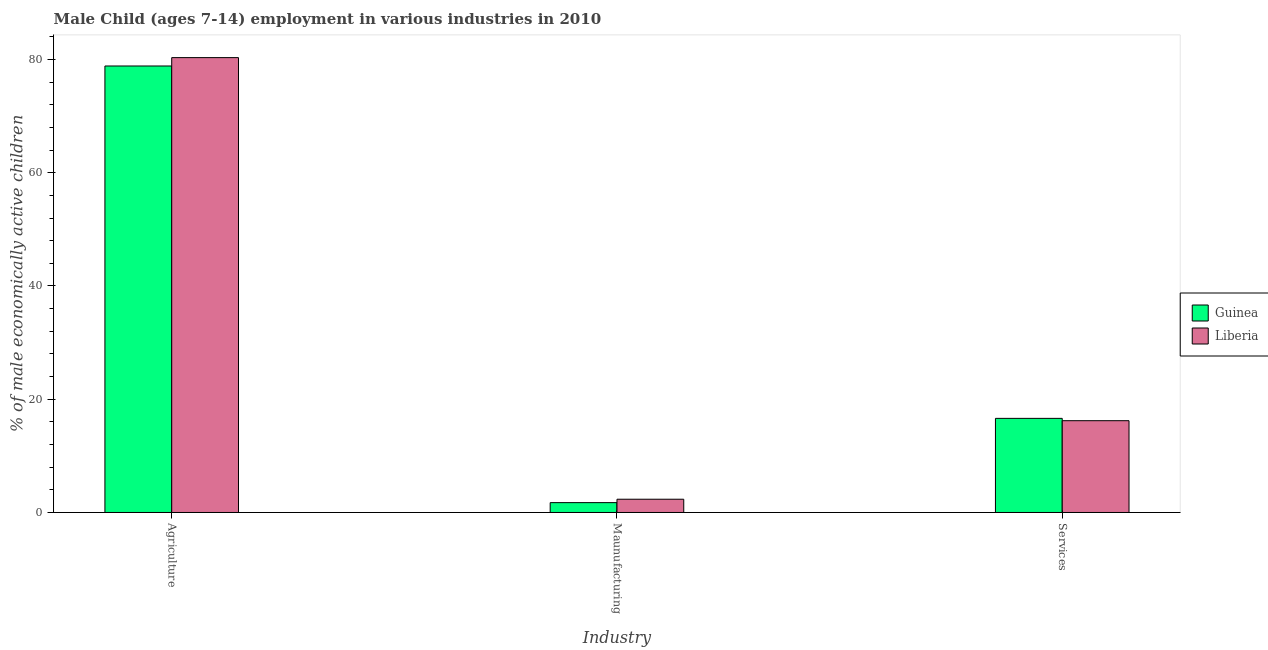How many groups of bars are there?
Ensure brevity in your answer.  3. Are the number of bars on each tick of the X-axis equal?
Provide a short and direct response. Yes. How many bars are there on the 2nd tick from the left?
Provide a short and direct response. 2. What is the label of the 3rd group of bars from the left?
Your answer should be very brief. Services. What is the percentage of economically active children in services in Liberia?
Your answer should be compact. 16.21. Across all countries, what is the maximum percentage of economically active children in services?
Your answer should be compact. 16.62. Across all countries, what is the minimum percentage of economically active children in agriculture?
Provide a succinct answer. 78.85. In which country was the percentage of economically active children in agriculture maximum?
Your answer should be very brief. Liberia. In which country was the percentage of economically active children in manufacturing minimum?
Ensure brevity in your answer.  Guinea. What is the total percentage of economically active children in agriculture in the graph?
Your answer should be compact. 159.18. What is the difference between the percentage of economically active children in agriculture in Guinea and that in Liberia?
Your response must be concise. -1.48. What is the difference between the percentage of economically active children in manufacturing in Guinea and the percentage of economically active children in agriculture in Liberia?
Offer a terse response. -78.59. What is the average percentage of economically active children in agriculture per country?
Ensure brevity in your answer.  79.59. What is the difference between the percentage of economically active children in services and percentage of economically active children in agriculture in Guinea?
Ensure brevity in your answer.  -62.23. What is the ratio of the percentage of economically active children in services in Liberia to that in Guinea?
Offer a very short reply. 0.98. Is the percentage of economically active children in manufacturing in Guinea less than that in Liberia?
Give a very brief answer. Yes. What is the difference between the highest and the second highest percentage of economically active children in agriculture?
Provide a succinct answer. 1.48. What is the difference between the highest and the lowest percentage of economically active children in manufacturing?
Your answer should be compact. 0.6. What does the 1st bar from the left in Maunufacturing represents?
Provide a short and direct response. Guinea. What does the 1st bar from the right in Maunufacturing represents?
Give a very brief answer. Liberia. How many countries are there in the graph?
Ensure brevity in your answer.  2. What is the difference between two consecutive major ticks on the Y-axis?
Offer a very short reply. 20. Does the graph contain any zero values?
Make the answer very short. No. Does the graph contain grids?
Give a very brief answer. No. Where does the legend appear in the graph?
Your answer should be compact. Center right. What is the title of the graph?
Provide a succinct answer. Male Child (ages 7-14) employment in various industries in 2010. What is the label or title of the X-axis?
Your answer should be very brief. Industry. What is the label or title of the Y-axis?
Keep it short and to the point. % of male economically active children. What is the % of male economically active children of Guinea in Agriculture?
Your answer should be very brief. 78.85. What is the % of male economically active children of Liberia in Agriculture?
Make the answer very short. 80.33. What is the % of male economically active children in Guinea in Maunufacturing?
Give a very brief answer. 1.74. What is the % of male economically active children of Liberia in Maunufacturing?
Your answer should be very brief. 2.34. What is the % of male economically active children of Guinea in Services?
Provide a short and direct response. 16.62. What is the % of male economically active children in Liberia in Services?
Provide a short and direct response. 16.21. Across all Industry, what is the maximum % of male economically active children of Guinea?
Provide a succinct answer. 78.85. Across all Industry, what is the maximum % of male economically active children in Liberia?
Your answer should be very brief. 80.33. Across all Industry, what is the minimum % of male economically active children in Guinea?
Your answer should be very brief. 1.74. Across all Industry, what is the minimum % of male economically active children of Liberia?
Ensure brevity in your answer.  2.34. What is the total % of male economically active children of Guinea in the graph?
Ensure brevity in your answer.  97.21. What is the total % of male economically active children of Liberia in the graph?
Offer a terse response. 98.88. What is the difference between the % of male economically active children in Guinea in Agriculture and that in Maunufacturing?
Offer a very short reply. 77.11. What is the difference between the % of male economically active children in Liberia in Agriculture and that in Maunufacturing?
Ensure brevity in your answer.  77.99. What is the difference between the % of male economically active children of Guinea in Agriculture and that in Services?
Keep it short and to the point. 62.23. What is the difference between the % of male economically active children of Liberia in Agriculture and that in Services?
Your response must be concise. 64.12. What is the difference between the % of male economically active children of Guinea in Maunufacturing and that in Services?
Your answer should be very brief. -14.88. What is the difference between the % of male economically active children of Liberia in Maunufacturing and that in Services?
Your response must be concise. -13.87. What is the difference between the % of male economically active children of Guinea in Agriculture and the % of male economically active children of Liberia in Maunufacturing?
Offer a terse response. 76.51. What is the difference between the % of male economically active children in Guinea in Agriculture and the % of male economically active children in Liberia in Services?
Keep it short and to the point. 62.64. What is the difference between the % of male economically active children in Guinea in Maunufacturing and the % of male economically active children in Liberia in Services?
Your answer should be very brief. -14.47. What is the average % of male economically active children of Guinea per Industry?
Your answer should be very brief. 32.4. What is the average % of male economically active children in Liberia per Industry?
Provide a short and direct response. 32.96. What is the difference between the % of male economically active children of Guinea and % of male economically active children of Liberia in Agriculture?
Give a very brief answer. -1.48. What is the difference between the % of male economically active children in Guinea and % of male economically active children in Liberia in Services?
Offer a terse response. 0.41. What is the ratio of the % of male economically active children of Guinea in Agriculture to that in Maunufacturing?
Offer a very short reply. 45.32. What is the ratio of the % of male economically active children of Liberia in Agriculture to that in Maunufacturing?
Ensure brevity in your answer.  34.33. What is the ratio of the % of male economically active children of Guinea in Agriculture to that in Services?
Keep it short and to the point. 4.74. What is the ratio of the % of male economically active children in Liberia in Agriculture to that in Services?
Your answer should be very brief. 4.96. What is the ratio of the % of male economically active children of Guinea in Maunufacturing to that in Services?
Your answer should be very brief. 0.1. What is the ratio of the % of male economically active children of Liberia in Maunufacturing to that in Services?
Offer a very short reply. 0.14. What is the difference between the highest and the second highest % of male economically active children in Guinea?
Ensure brevity in your answer.  62.23. What is the difference between the highest and the second highest % of male economically active children in Liberia?
Keep it short and to the point. 64.12. What is the difference between the highest and the lowest % of male economically active children of Guinea?
Offer a very short reply. 77.11. What is the difference between the highest and the lowest % of male economically active children of Liberia?
Ensure brevity in your answer.  77.99. 